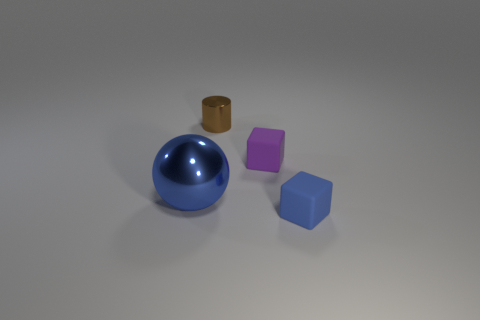What number of brown metal cylinders have the same size as the purple object?
Your answer should be compact. 1. Are there fewer matte things that are behind the tiny blue object than matte objects on the right side of the tiny purple block?
Keep it short and to the point. No. What number of metallic objects are tiny yellow balls or small brown objects?
Keep it short and to the point. 1. What shape is the big blue object?
Give a very brief answer. Sphere. What is the material of the blue thing that is the same size as the brown object?
Provide a succinct answer. Rubber. How many large things are either cyan metal blocks or blue blocks?
Give a very brief answer. 0. Are there any tiny green metallic blocks?
Your answer should be very brief. No. The blue ball that is the same material as the brown object is what size?
Your answer should be compact. Large. Is the material of the small purple block the same as the big ball?
Offer a terse response. No. How many other things are made of the same material as the brown cylinder?
Make the answer very short. 1. 